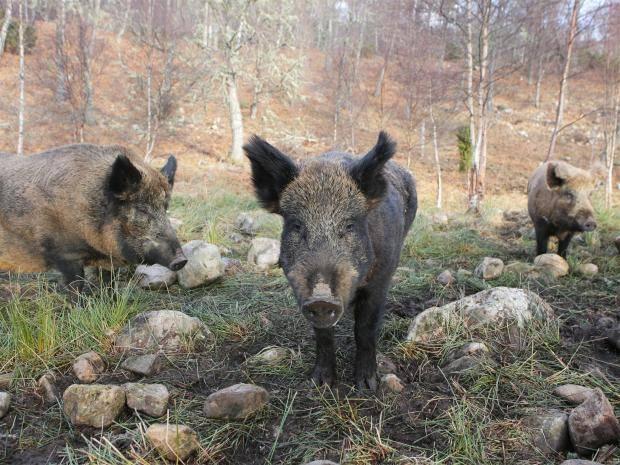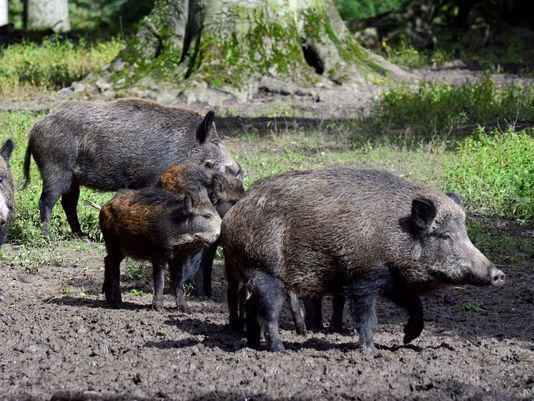The first image is the image on the left, the second image is the image on the right. Considering the images on both sides, is "An image shows one walking boar in full head and body profile." valid? Answer yes or no. No. The first image is the image on the left, the second image is the image on the right. Examine the images to the left and right. Is the description "There are at most 3 hogs total." accurate? Answer yes or no. No. 